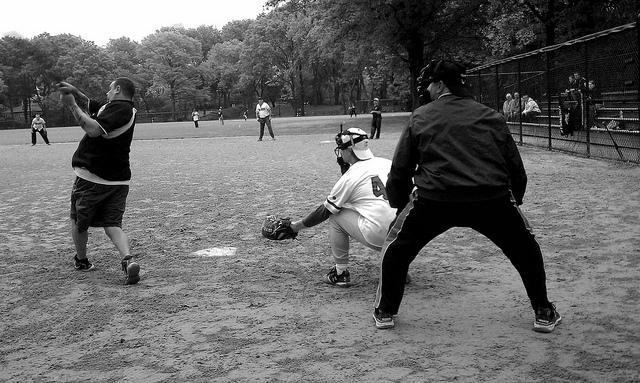What are these people playing?
Concise answer only. Baseball. Is this a Little League team?
Be succinct. No. How many men are playing baseball?
Concise answer only. 5. How can you tell this is not a professional team?
Give a very brief answer. No uniforms. 